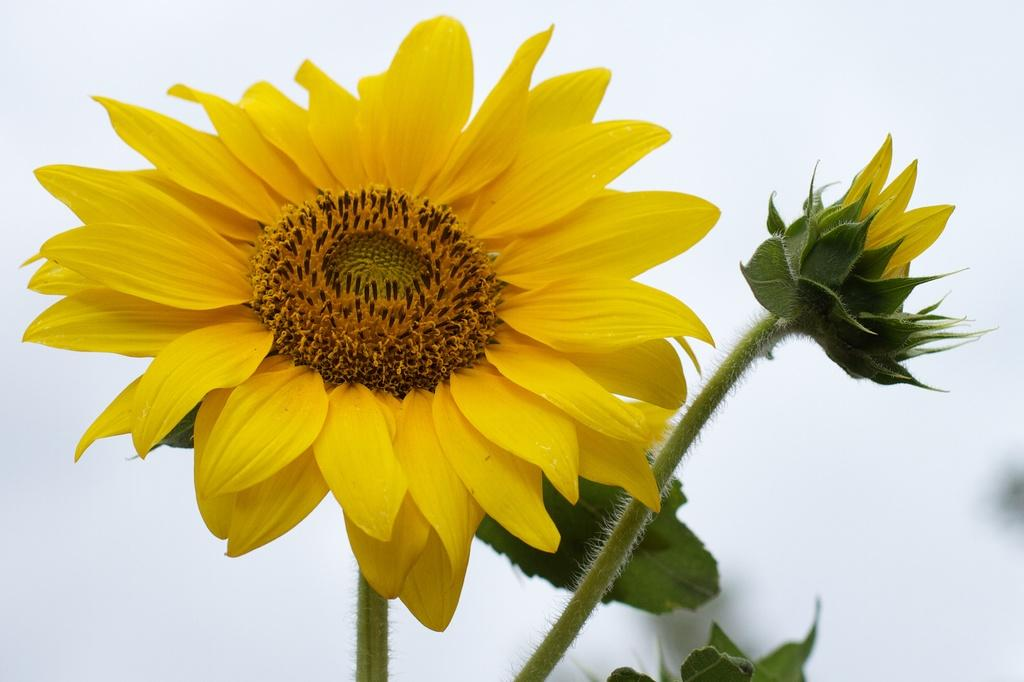What type of plant is in the image? There is a sunflower in the image. Can you describe the main part of the sunflower? The sunflower has a stem. What type of bone can be seen in the sunflower's nest in the image? There is no bone or nest present in the image; it features a sunflower with a stem. What type of soup is being served in the sunflower's bowl in the image? There is no soup or bowl present in the image; it features a sunflower with a stem. 